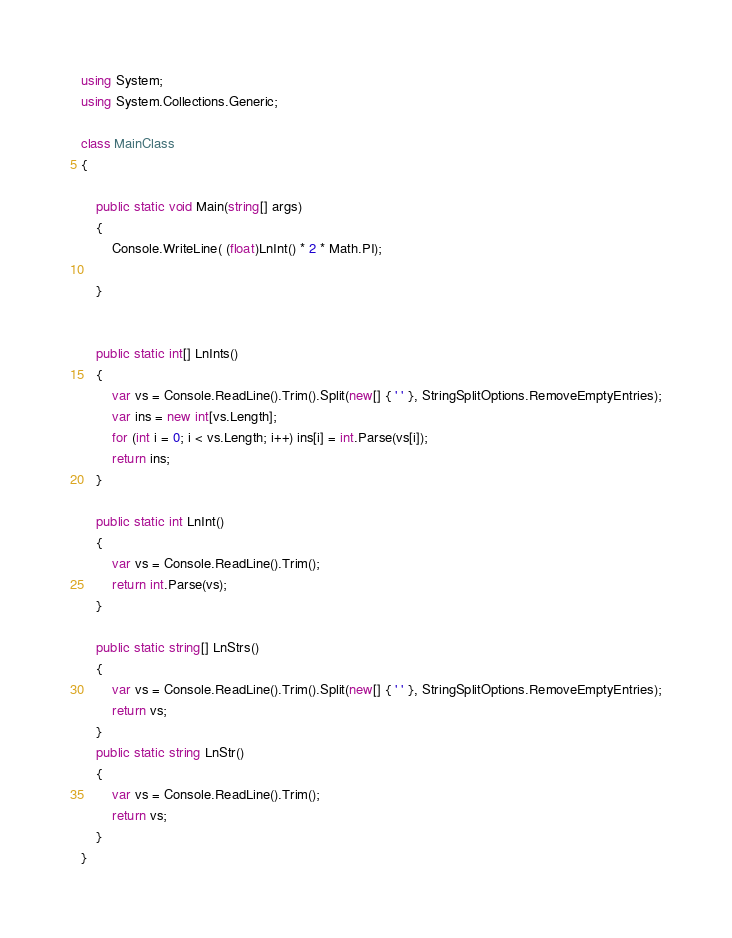<code> <loc_0><loc_0><loc_500><loc_500><_C#_>using System;
using System.Collections.Generic;

class MainClass
{
   
    public static void Main(string[] args)
    {
        Console.WriteLine( (float)LnInt() * 2 * Math.PI);

    }

   
    public static int[] LnInts()
    {
        var vs = Console.ReadLine().Trim().Split(new[] { ' ' }, StringSplitOptions.RemoveEmptyEntries);
        var ins = new int[vs.Length];
        for (int i = 0; i < vs.Length; i++) ins[i] = int.Parse(vs[i]);
        return ins;
    }

    public static int LnInt()
    {
        var vs = Console.ReadLine().Trim();
        return int.Parse(vs);
    }

    public static string[] LnStrs()
    {
        var vs = Console.ReadLine().Trim().Split(new[] { ' ' }, StringSplitOptions.RemoveEmptyEntries);
        return vs;
    }
    public static string LnStr()
    {
        var vs = Console.ReadLine().Trim();
        return vs;
    }
}</code> 